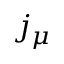<formula> <loc_0><loc_0><loc_500><loc_500>j _ { \mu }</formula> 